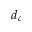<formula> <loc_0><loc_0><loc_500><loc_500>d _ { c }</formula> 